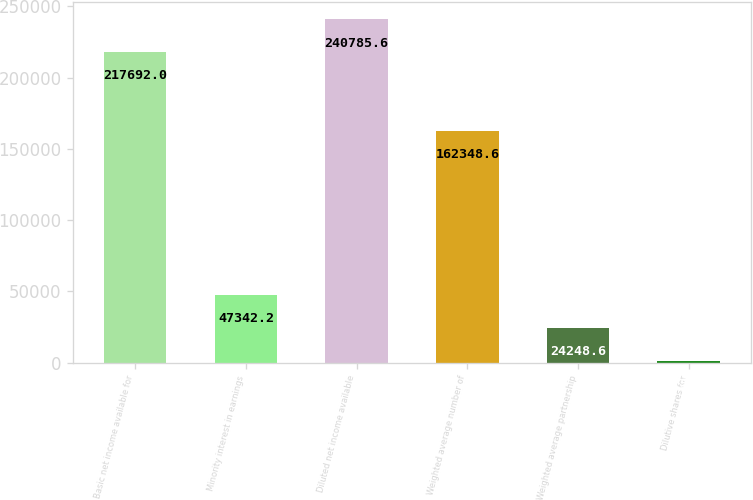Convert chart. <chart><loc_0><loc_0><loc_500><loc_500><bar_chart><fcel>Basic net income available for<fcel>Minority interest in earnings<fcel>Diluted net income available<fcel>Weighted average number of<fcel>Weighted average partnership<fcel>Dilutive shares for<nl><fcel>217692<fcel>47342.2<fcel>240786<fcel>162349<fcel>24248.6<fcel>1155<nl></chart> 